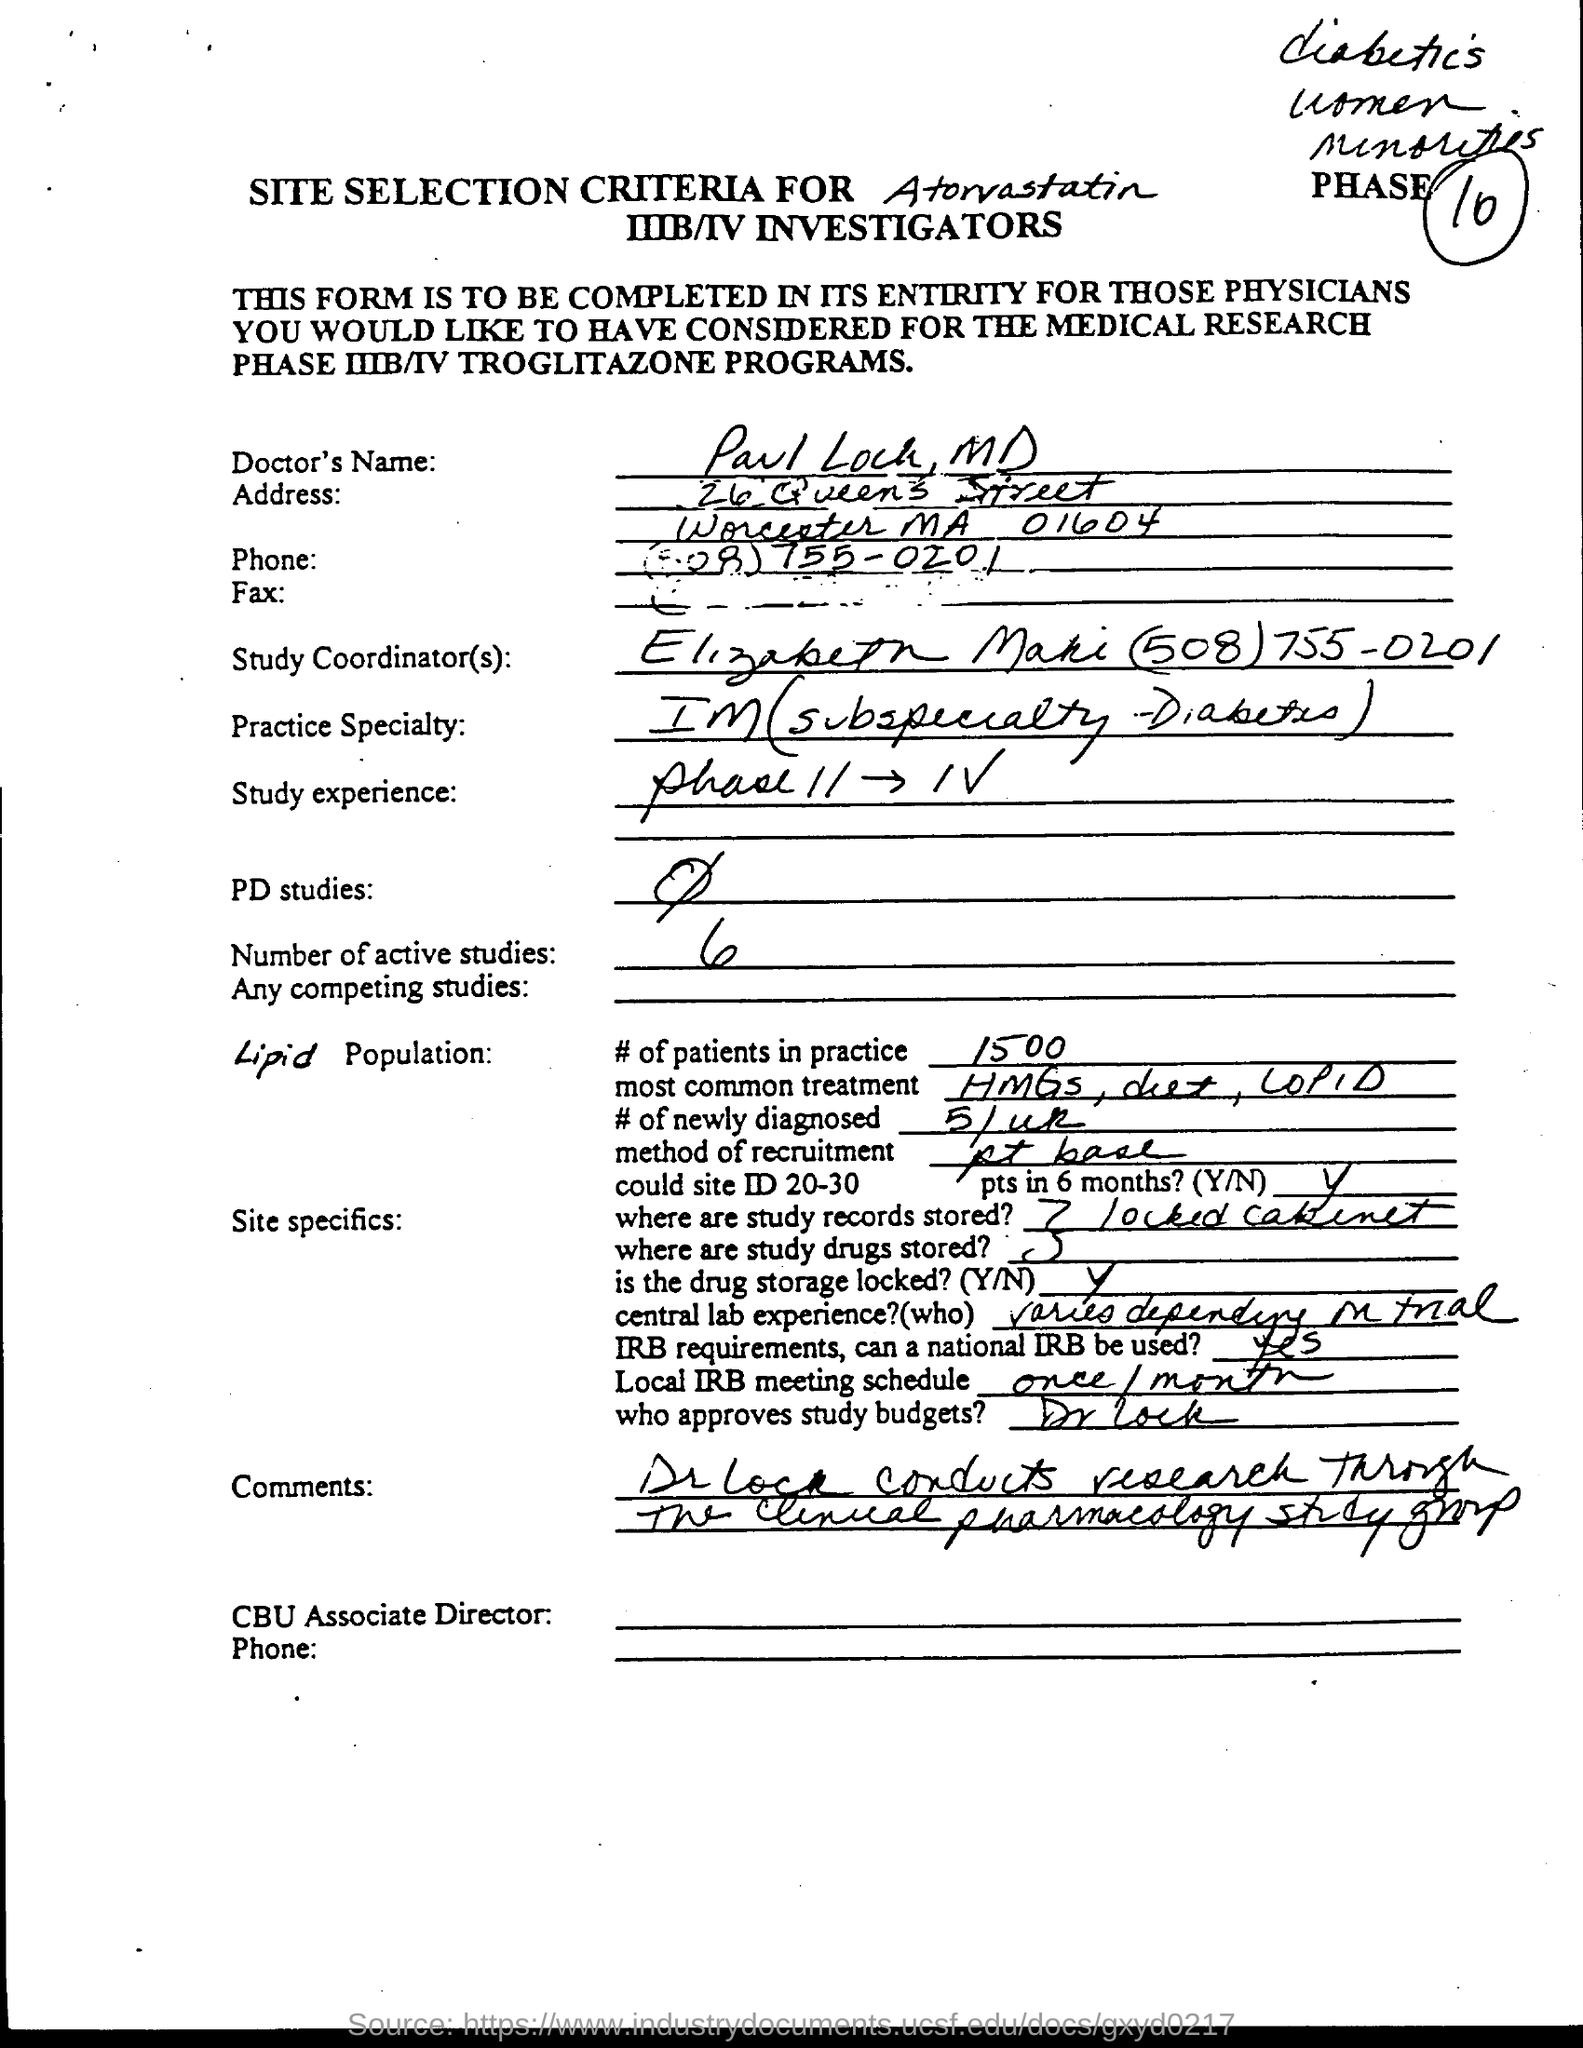What is the Doctor's Name?
Ensure brevity in your answer.  Paul Lock. Who is the Study Coordinator?
Offer a terse response. Elizabeth Maki (508) 755-0201. What is the Practice speciality?
Make the answer very short. IM(subspeciality - Diabetes). What is the Study experience?
Keep it short and to the point. Phase ii - iv. What are the Number of Active studies?
Make the answer very short. 6. What are the # of patients in practice?
Your answer should be very brief. 1500. What is the most common treatment?
Keep it short and to the point. HMGs, diet, COPID. Where are the study records stored?
Ensure brevity in your answer.  7 locked cabinet. What is the local IRB meeting schedule?
Offer a terse response. Once/month. Who approves study budgets?
Offer a terse response. Dr. Lock. 